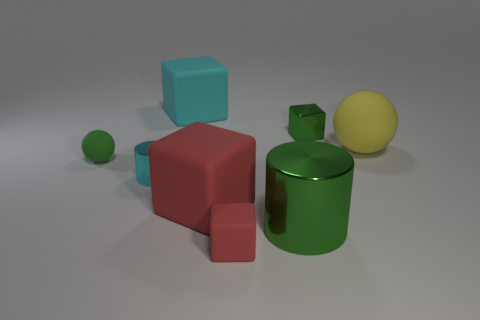Subtract all large red rubber cubes. How many cubes are left? 3 Subtract all yellow cylinders. How many red blocks are left? 2 Add 1 small green rubber spheres. How many objects exist? 9 Subtract all red cubes. How many cubes are left? 2 Subtract all balls. How many objects are left? 6 Subtract 1 cylinders. How many cylinders are left? 1 Add 1 tiny cyan metallic balls. How many tiny cyan metallic balls exist? 1 Subtract 0 blue cylinders. How many objects are left? 8 Subtract all cyan balls. Subtract all brown blocks. How many balls are left? 2 Subtract all small red metallic objects. Subtract all big cyan matte blocks. How many objects are left? 7 